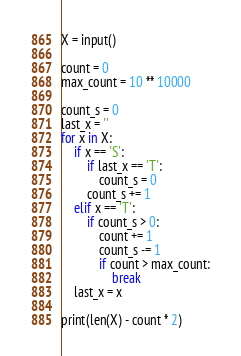Convert code to text. <code><loc_0><loc_0><loc_500><loc_500><_Python_>X = input()

count = 0
max_count = 10 ** 10000

count_s = 0
last_x = ''
for x in X:
    if x == 'S':
        if last_x == 'T':
            count_s = 0
        count_s += 1
    elif x == 'T':
        if count_s > 0:
            count += 1
            count_s -= 1
            if count > max_count:
                break
    last_x = x

print(len(X) - count * 2)
</code> 